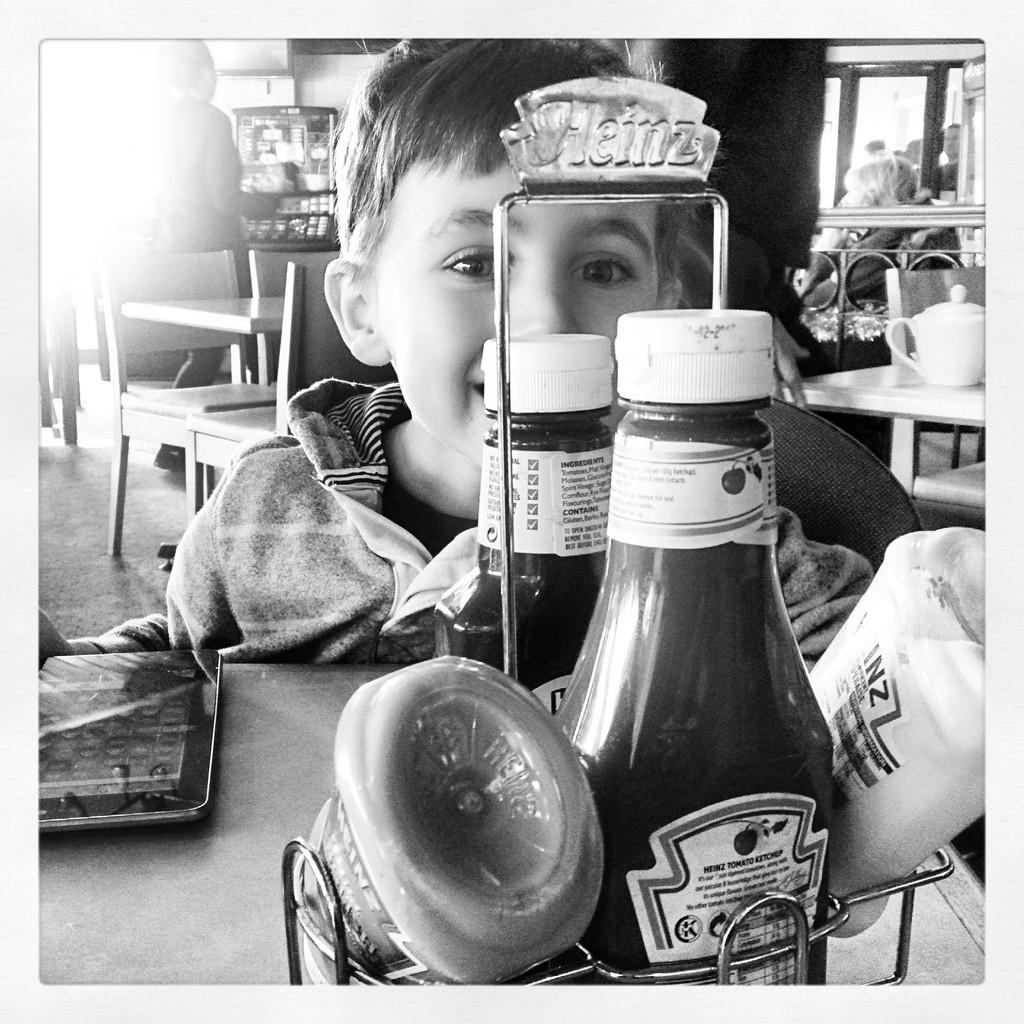What is the color scheme of the image? The image is black and white. Who is present in the image? There is a kid in the image. What is in front of the kid? There is a table in front of the kid. What items are on the table? There are bottles and an iPad on the table. What type of furniture is visible in the image? There are chairs and tables visible in the image. What type of monkey is sitting on the lawyer's shoulder in the image? There is no monkey or lawyer present in the image. 